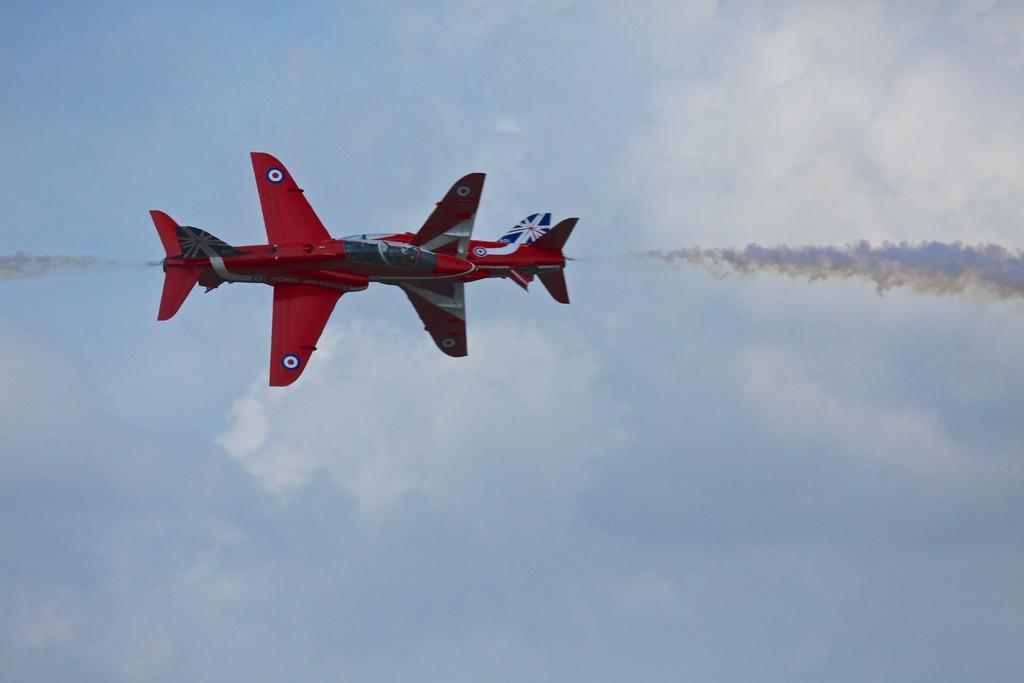What is the main subject of the image? The main subject of the image is two aeroplanes. What are the aeroplanes doing in the image? The aeroplanes are flying in the air. What is the color of the aeroplanes? The aeroplanes are red in color. How would you describe the sky in the image? The sky is cloudy in the image. What type of cap is the representative wearing while standing on top of the aeroplane in the image? There is no representative or cap present in the image; it only features two red aeroplanes flying in the cloudy sky. 